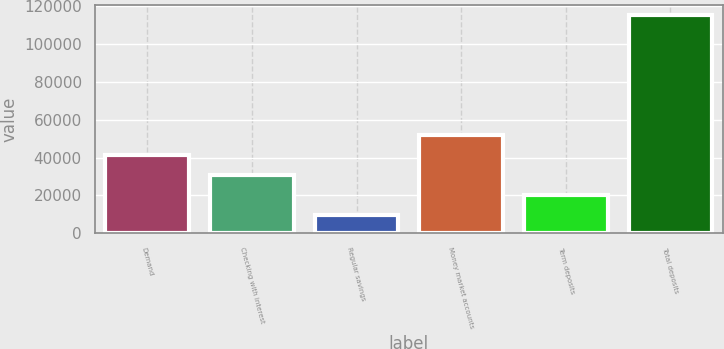<chart> <loc_0><loc_0><loc_500><loc_500><bar_chart><fcel>Demand<fcel>Checking with interest<fcel>Regular savings<fcel>Money market accounts<fcel>Term deposits<fcel>Total deposits<nl><fcel>41189.3<fcel>30632.2<fcel>9518<fcel>51746.4<fcel>20075.1<fcel>115089<nl></chart> 